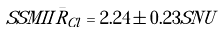<formula> <loc_0><loc_0><loc_500><loc_500>S S M I I \bar { R } _ { C l } = 2 . 2 4 \pm 0 . 2 3 S N U</formula> 